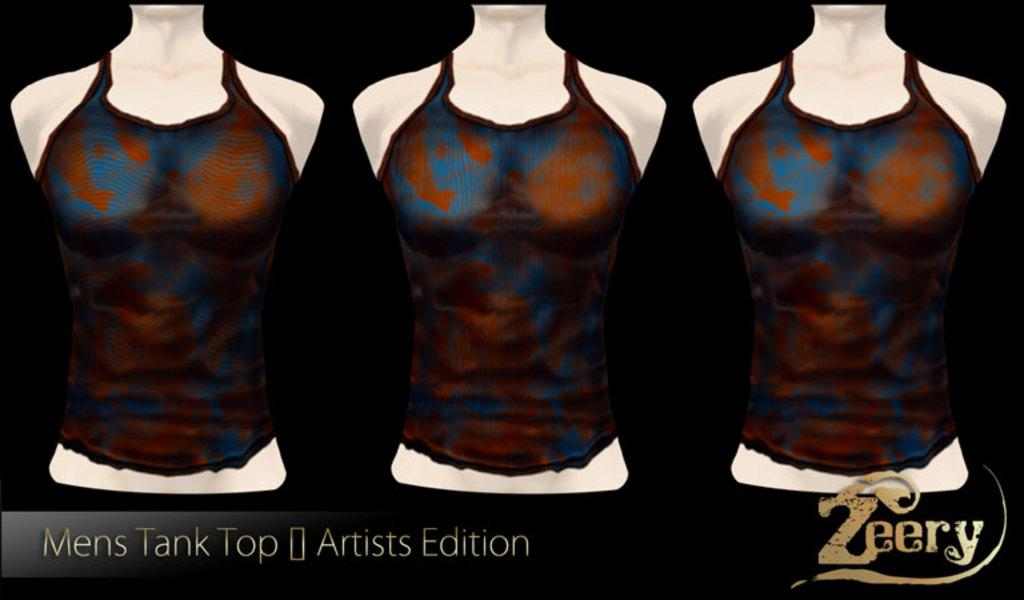What type of objects are present in the image? There are mannequins in the image. What type of juice is being served by the mannequin in the image? There is no juice or mannequin serving it in the image; there are only mannequins present. 